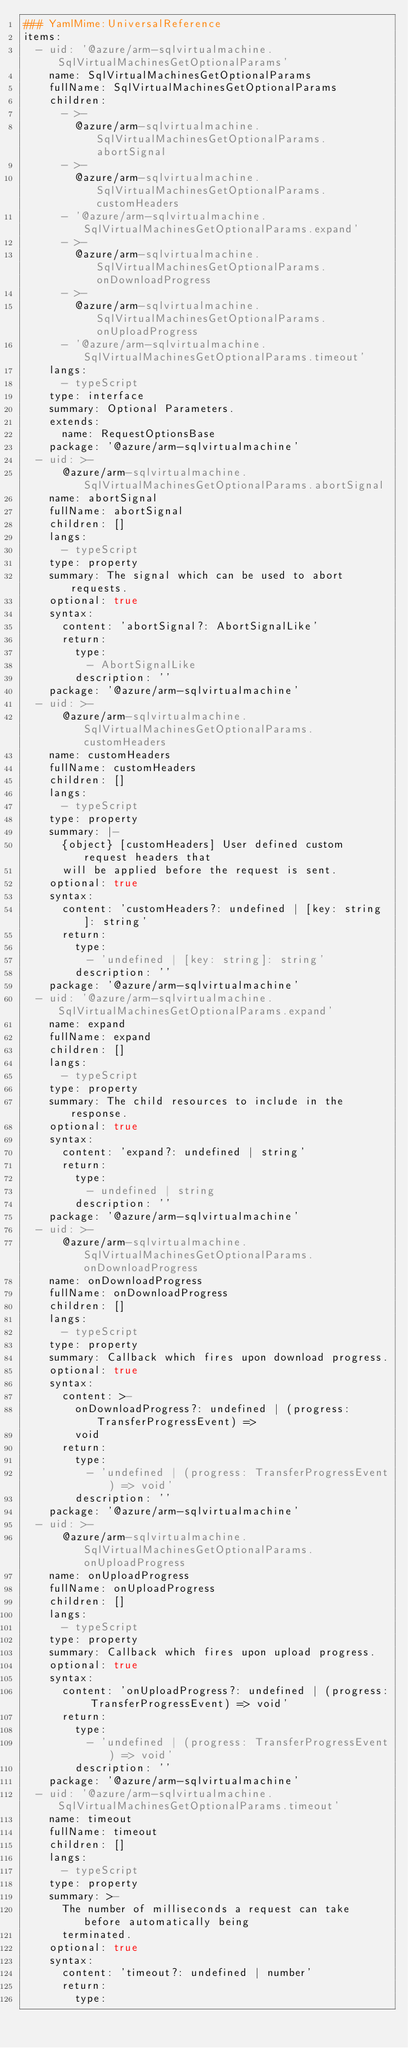Convert code to text. <code><loc_0><loc_0><loc_500><loc_500><_YAML_>### YamlMime:UniversalReference
items:
  - uid: '@azure/arm-sqlvirtualmachine.SqlVirtualMachinesGetOptionalParams'
    name: SqlVirtualMachinesGetOptionalParams
    fullName: SqlVirtualMachinesGetOptionalParams
    children:
      - >-
        @azure/arm-sqlvirtualmachine.SqlVirtualMachinesGetOptionalParams.abortSignal
      - >-
        @azure/arm-sqlvirtualmachine.SqlVirtualMachinesGetOptionalParams.customHeaders
      - '@azure/arm-sqlvirtualmachine.SqlVirtualMachinesGetOptionalParams.expand'
      - >-
        @azure/arm-sqlvirtualmachine.SqlVirtualMachinesGetOptionalParams.onDownloadProgress
      - >-
        @azure/arm-sqlvirtualmachine.SqlVirtualMachinesGetOptionalParams.onUploadProgress
      - '@azure/arm-sqlvirtualmachine.SqlVirtualMachinesGetOptionalParams.timeout'
    langs:
      - typeScript
    type: interface
    summary: Optional Parameters.
    extends:
      name: RequestOptionsBase
    package: '@azure/arm-sqlvirtualmachine'
  - uid: >-
      @azure/arm-sqlvirtualmachine.SqlVirtualMachinesGetOptionalParams.abortSignal
    name: abortSignal
    fullName: abortSignal
    children: []
    langs:
      - typeScript
    type: property
    summary: The signal which can be used to abort requests.
    optional: true
    syntax:
      content: 'abortSignal?: AbortSignalLike'
      return:
        type:
          - AbortSignalLike
        description: ''
    package: '@azure/arm-sqlvirtualmachine'
  - uid: >-
      @azure/arm-sqlvirtualmachine.SqlVirtualMachinesGetOptionalParams.customHeaders
    name: customHeaders
    fullName: customHeaders
    children: []
    langs:
      - typeScript
    type: property
    summary: |-
      {object} [customHeaders] User defined custom request headers that
      will be applied before the request is sent.
    optional: true
    syntax:
      content: 'customHeaders?: undefined | [key: string]: string'
      return:
        type:
          - 'undefined | [key: string]: string'
        description: ''
    package: '@azure/arm-sqlvirtualmachine'
  - uid: '@azure/arm-sqlvirtualmachine.SqlVirtualMachinesGetOptionalParams.expand'
    name: expand
    fullName: expand
    children: []
    langs:
      - typeScript
    type: property
    summary: The child resources to include in the response.
    optional: true
    syntax:
      content: 'expand?: undefined | string'
      return:
        type:
          - undefined | string
        description: ''
    package: '@azure/arm-sqlvirtualmachine'
  - uid: >-
      @azure/arm-sqlvirtualmachine.SqlVirtualMachinesGetOptionalParams.onDownloadProgress
    name: onDownloadProgress
    fullName: onDownloadProgress
    children: []
    langs:
      - typeScript
    type: property
    summary: Callback which fires upon download progress.
    optional: true
    syntax:
      content: >-
        onDownloadProgress?: undefined | (progress: TransferProgressEvent) =>
        void
      return:
        type:
          - 'undefined | (progress: TransferProgressEvent) => void'
        description: ''
    package: '@azure/arm-sqlvirtualmachine'
  - uid: >-
      @azure/arm-sqlvirtualmachine.SqlVirtualMachinesGetOptionalParams.onUploadProgress
    name: onUploadProgress
    fullName: onUploadProgress
    children: []
    langs:
      - typeScript
    type: property
    summary: Callback which fires upon upload progress.
    optional: true
    syntax:
      content: 'onUploadProgress?: undefined | (progress: TransferProgressEvent) => void'
      return:
        type:
          - 'undefined | (progress: TransferProgressEvent) => void'
        description: ''
    package: '@azure/arm-sqlvirtualmachine'
  - uid: '@azure/arm-sqlvirtualmachine.SqlVirtualMachinesGetOptionalParams.timeout'
    name: timeout
    fullName: timeout
    children: []
    langs:
      - typeScript
    type: property
    summary: >-
      The number of milliseconds a request can take before automatically being
      terminated.
    optional: true
    syntax:
      content: 'timeout?: undefined | number'
      return:
        type:</code> 